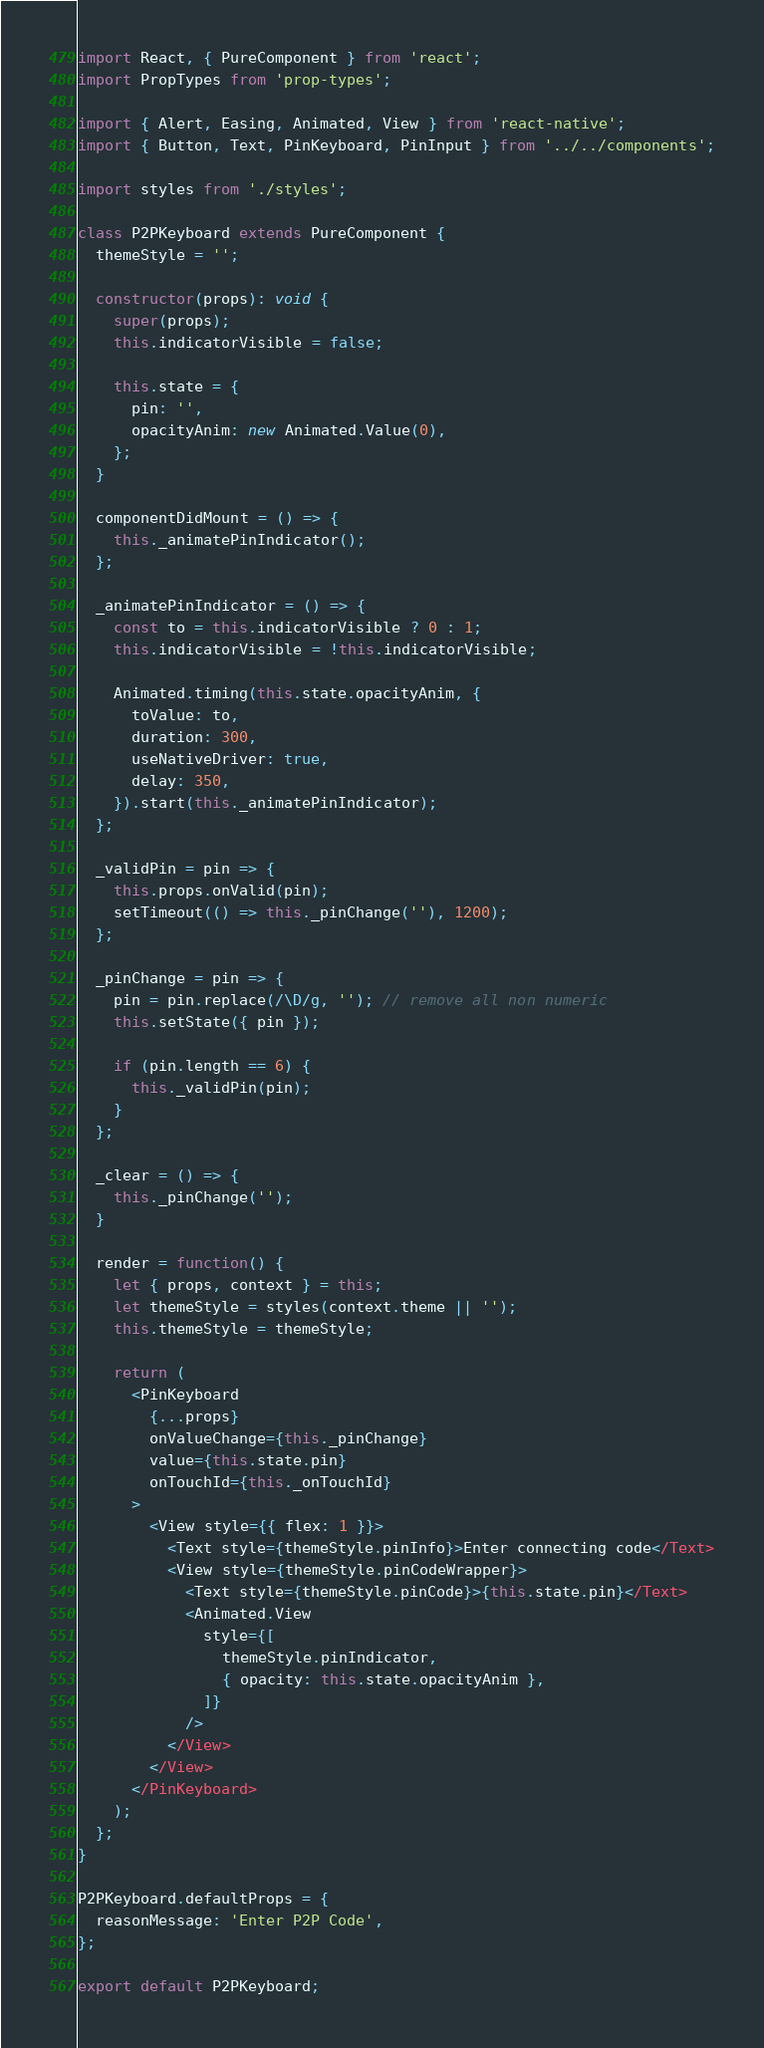Convert code to text. <code><loc_0><loc_0><loc_500><loc_500><_JavaScript_>import React, { PureComponent } from 'react';
import PropTypes from 'prop-types';

import { Alert, Easing, Animated, View } from 'react-native';
import { Button, Text, PinKeyboard, PinInput } from '../../components';

import styles from './styles';

class P2PKeyboard extends PureComponent {
  themeStyle = '';

  constructor(props): void {
    super(props);
    this.indicatorVisible = false;

    this.state = {
      pin: '',
      opacityAnim: new Animated.Value(0),
    };
  }

  componentDidMount = () => {
    this._animatePinIndicator();
  };

  _animatePinIndicator = () => {
    const to = this.indicatorVisible ? 0 : 1;
    this.indicatorVisible = !this.indicatorVisible;

    Animated.timing(this.state.opacityAnim, {
      toValue: to,
      duration: 300,
      useNativeDriver: true,
      delay: 350,
    }).start(this._animatePinIndicator);
  };

  _validPin = pin => {
    this.props.onValid(pin);
    setTimeout(() => this._pinChange(''), 1200);
  };

  _pinChange = pin => {
    pin = pin.replace(/\D/g, ''); // remove all non numeric
    this.setState({ pin });

    if (pin.length == 6) {
      this._validPin(pin);
    }
  };

  _clear = () => {
    this._pinChange('');
  }

  render = function() {
    let { props, context } = this;
    let themeStyle = styles(context.theme || '');
    this.themeStyle = themeStyle;

    return (
      <PinKeyboard
        {...props}
        onValueChange={this._pinChange}
        value={this.state.pin}
        onTouchId={this._onTouchId}
      >
        <View style={{ flex: 1 }}>
          <Text style={themeStyle.pinInfo}>Enter connecting code</Text>
          <View style={themeStyle.pinCodeWrapper}>
            <Text style={themeStyle.pinCode}>{this.state.pin}</Text>
            <Animated.View
              style={[
                themeStyle.pinIndicator,
                { opacity: this.state.opacityAnim },
              ]}
            />
          </View>
        </View>
      </PinKeyboard>
    );
  };
}

P2PKeyboard.defaultProps = {
  reasonMessage: 'Enter P2P Code',
};

export default P2PKeyboard;
</code> 